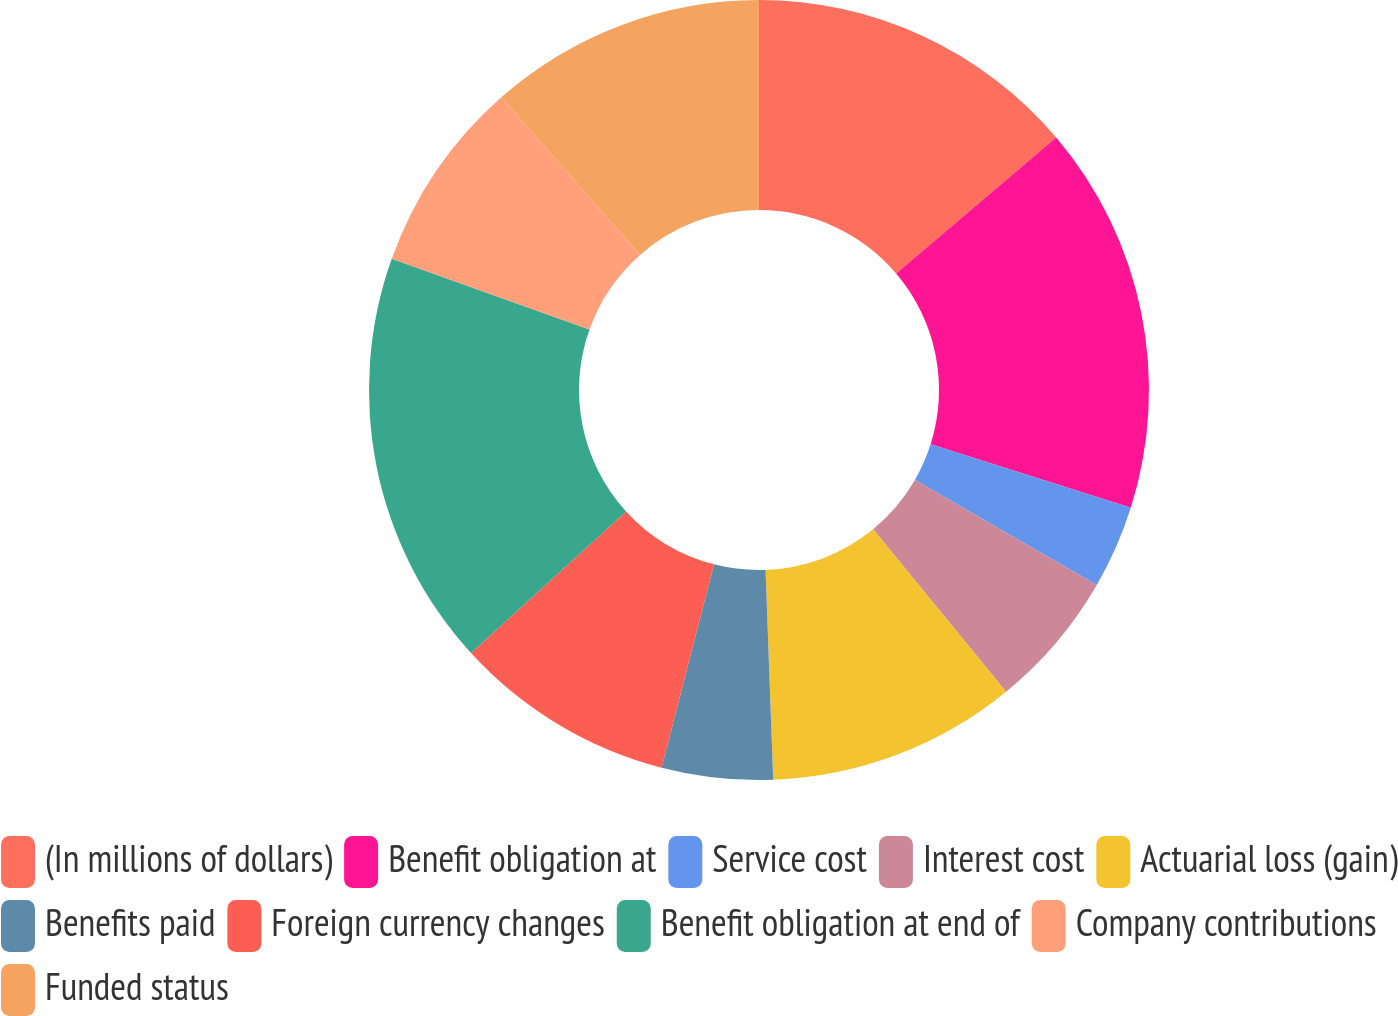<chart> <loc_0><loc_0><loc_500><loc_500><pie_chart><fcel>(In millions of dollars)<fcel>Benefit obligation at<fcel>Service cost<fcel>Interest cost<fcel>Actuarial loss (gain)<fcel>Benefits paid<fcel>Foreign currency changes<fcel>Benefit obligation at end of<fcel>Company contributions<fcel>Funded status<nl><fcel>13.79%<fcel>16.09%<fcel>3.45%<fcel>5.75%<fcel>10.34%<fcel>4.6%<fcel>9.2%<fcel>17.24%<fcel>8.05%<fcel>11.49%<nl></chart> 